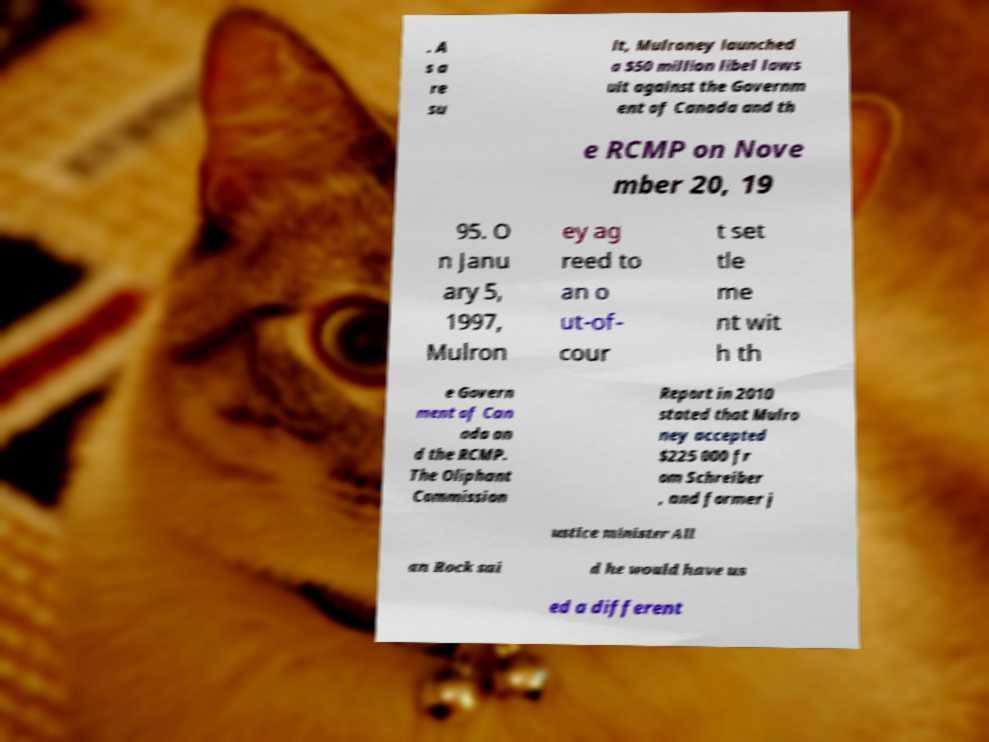Could you assist in decoding the text presented in this image and type it out clearly? . A s a re su lt, Mulroney launched a $50 million libel laws uit against the Governm ent of Canada and th e RCMP on Nove mber 20, 19 95. O n Janu ary 5, 1997, Mulron ey ag reed to an o ut-of- cour t set tle me nt wit h th e Govern ment of Can ada an d the RCMP. The Oliphant Commission Report in 2010 stated that Mulro ney accepted $225 000 fr om Schreiber , and former j ustice minister All an Rock sai d he would have us ed a different 